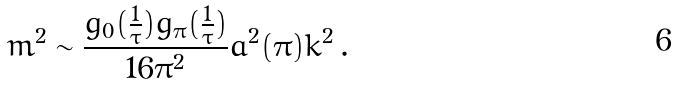Convert formula to latex. <formula><loc_0><loc_0><loc_500><loc_500>m ^ { 2 } \sim \frac { g _ { 0 } ( \frac { 1 } { \tau } ) g _ { \pi } ( \frac { 1 } { \tau } ) } { 1 6 \pi ^ { 2 } } a ^ { 2 } ( \pi ) k ^ { 2 } \, .</formula> 